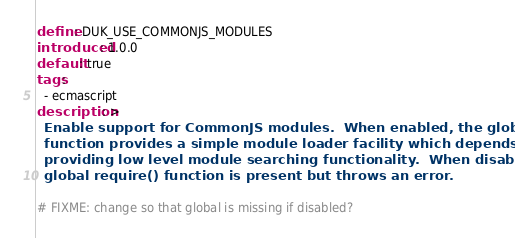Convert code to text. <code><loc_0><loc_0><loc_500><loc_500><_YAML_>define: DUK_USE_COMMONJS_MODULES
introduced: 1.0.0
default: true
tags:
  - ecmascript
description: >
  Enable support for CommonJS modules.  When enabled, the global require()
  function provides a simple module loader facility which depends on the user
  providing low level module searching functionality.  When disabled, the
  global require() function is present but throws an error.

# FIXME: change so that global is missing if disabled?
</code> 